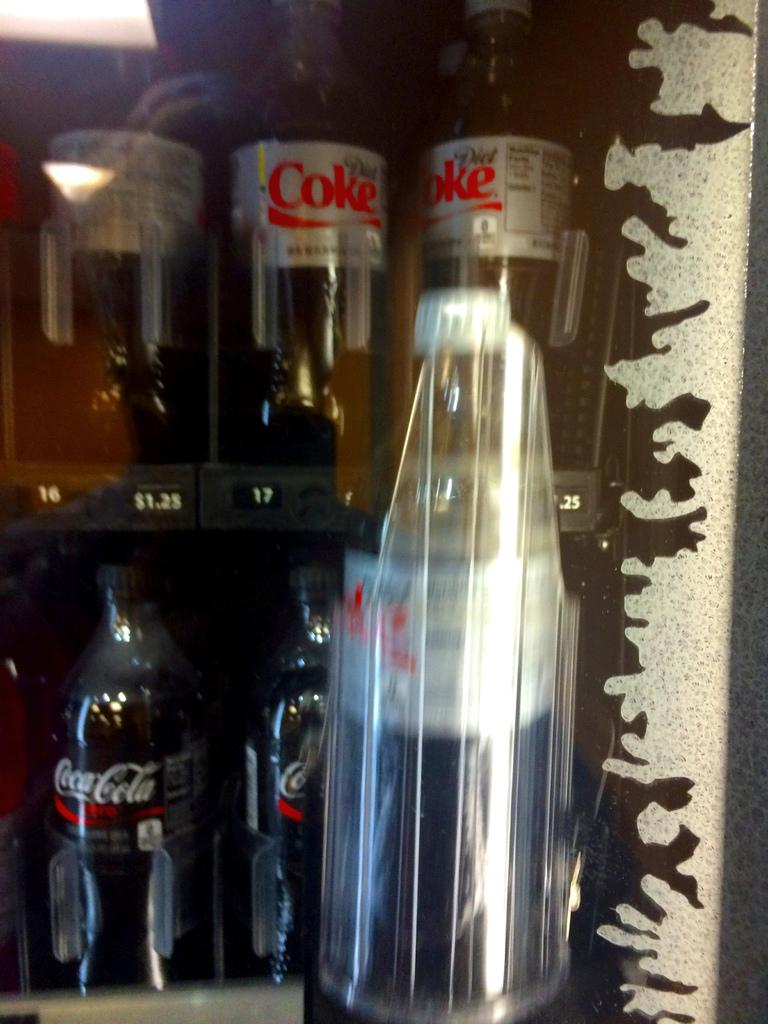<image>
Relay a brief, clear account of the picture shown. Plastic bottles of diet coke and coke zero in the vending machine. 